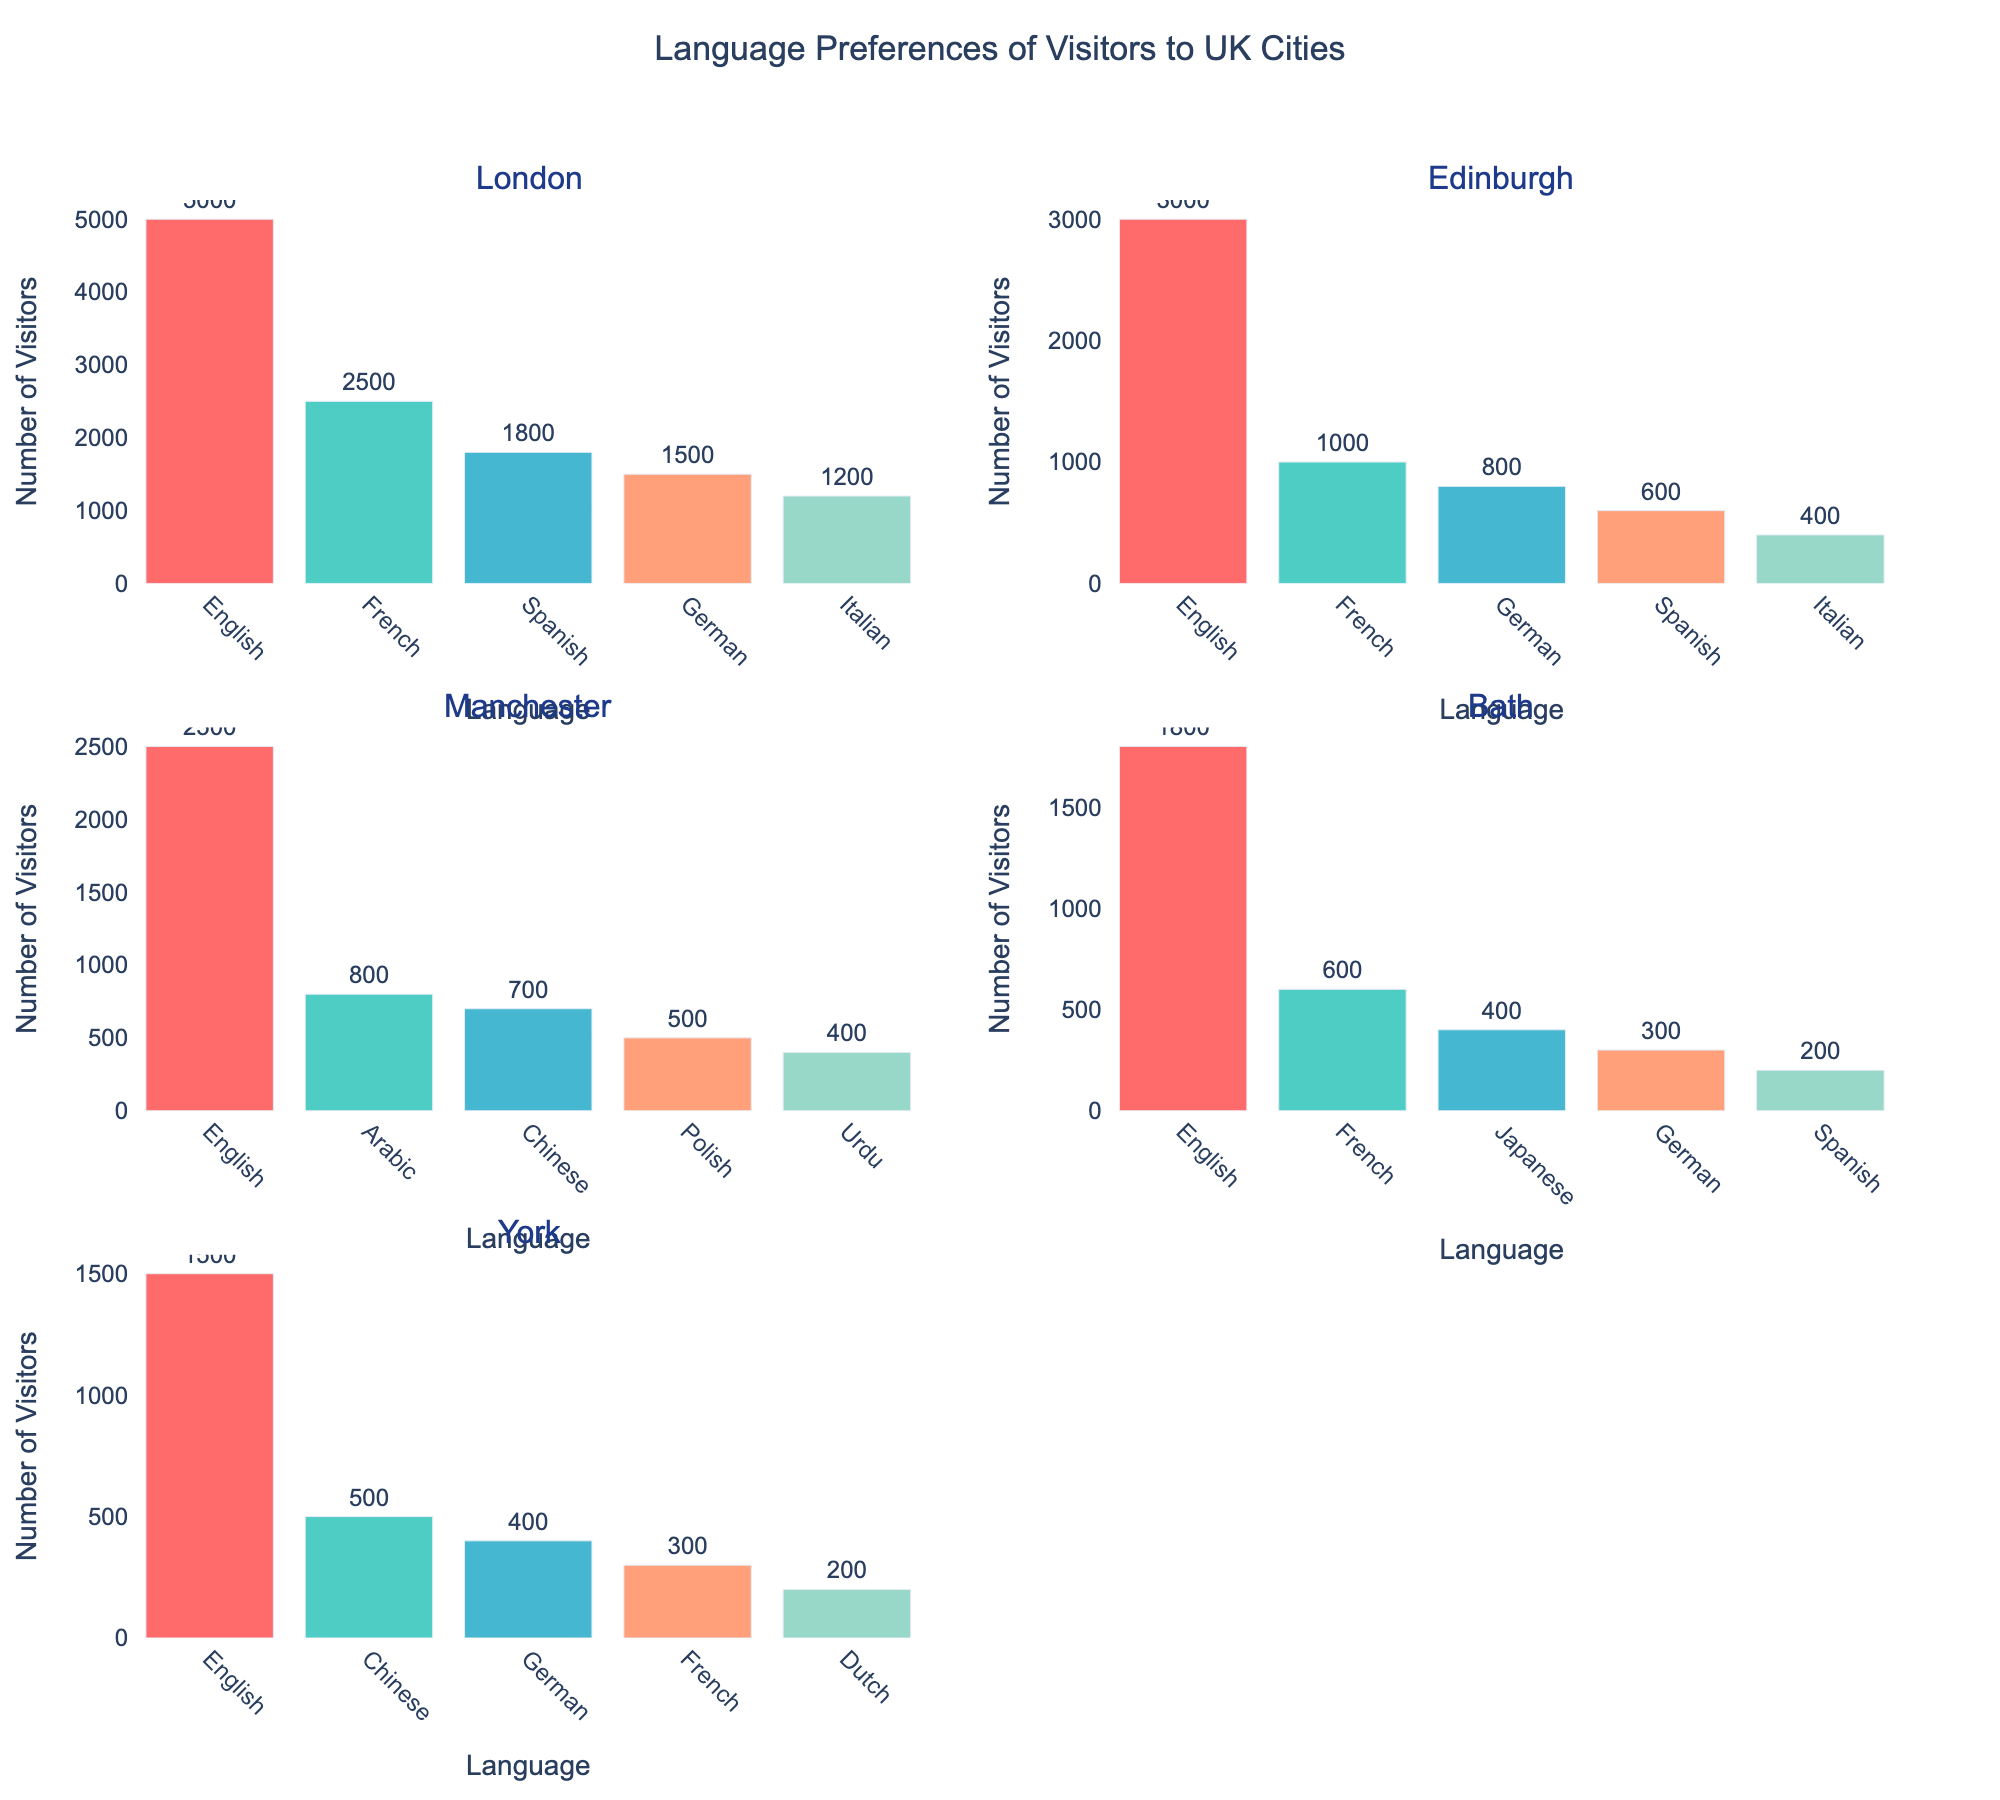What is the title of the figure? The title is displayed at the top center of the figure, stating the overall theme of the plots, which is "Language Preferences of Visitors to UK Cities."
Answer: Language Preferences of Visitors to UK Cities Which city has the highest number of visits from French speakers? Inspect the bar heights for French speakers across all the subplots. For London, it’s around 2500; for Edinburgh, it’s 1000; for Manchester, there is no data; for Bath, it’s 600; for York, it's 300. Therefore, London has the highest number of visits from French speakers.
Answer: London In which city do Spanish speakers rank third in visitor numbers? Look at the subplot for each city, find the bar representing Spanish speakers, and determine its rank based on height. For London, Spanish speakers are third after English and French. For Edinburgh, they are fourth. For Manchester, there is no data for Spanish speakers. For Bath, Spanish speakers are fifth. For York, Spanish speakers are not among the top five.
Answer: London What is the total number of visitors to Edinburgh? Sum the visitor numbers for all the languages in the Edinburgh subplot: 3000 (English) + 1000 (French) + 800 (German) + 600 (Spanish) + 400 (Italian).
Answer: 5800 Which city shows the highest diversity of languages? Count the number of different languages listed in each subplot. London has 5, Edinburgh has 5, Manchester has 4, Bath has 5, and York has 5. All cities except Manchester show the highest language diversity.
Answer: London, Edinburgh, Bath, York Comparing Bath and York, which city has more visitors who speak German? Check the bar heights for German speakers in Bath and York subplots. Bath has about 300 German-speaking visitors, while York has about 400. So, York has more visitors who speak German.
Answer: York What's the most popular language in Manchester? Identify which bar has the greatest height in the Manchester subplot. The English bar is the tallest one, far taller than the others listed.
Answer: English How many more visitors prefer speaking English in London than in Edinburgh? Calculate the difference in the number of English-speaking visitors between London and Edinburgh: 5000 (London) - 3000 (Edinburgh).
Answer: 2000 In which city do visitors speaking Arabic rank second? Examine the subplots to determine where Arabic falls in the rank order based on bar heights. Only Manchester has data for Arabic, and it is shown second after English.
Answer: Manchester What is the least common language among visitors to York? Find the bar with the smallest height in York's subplot. Dutch has the smallest number, with around 200 visitors.
Answer: Dutch 